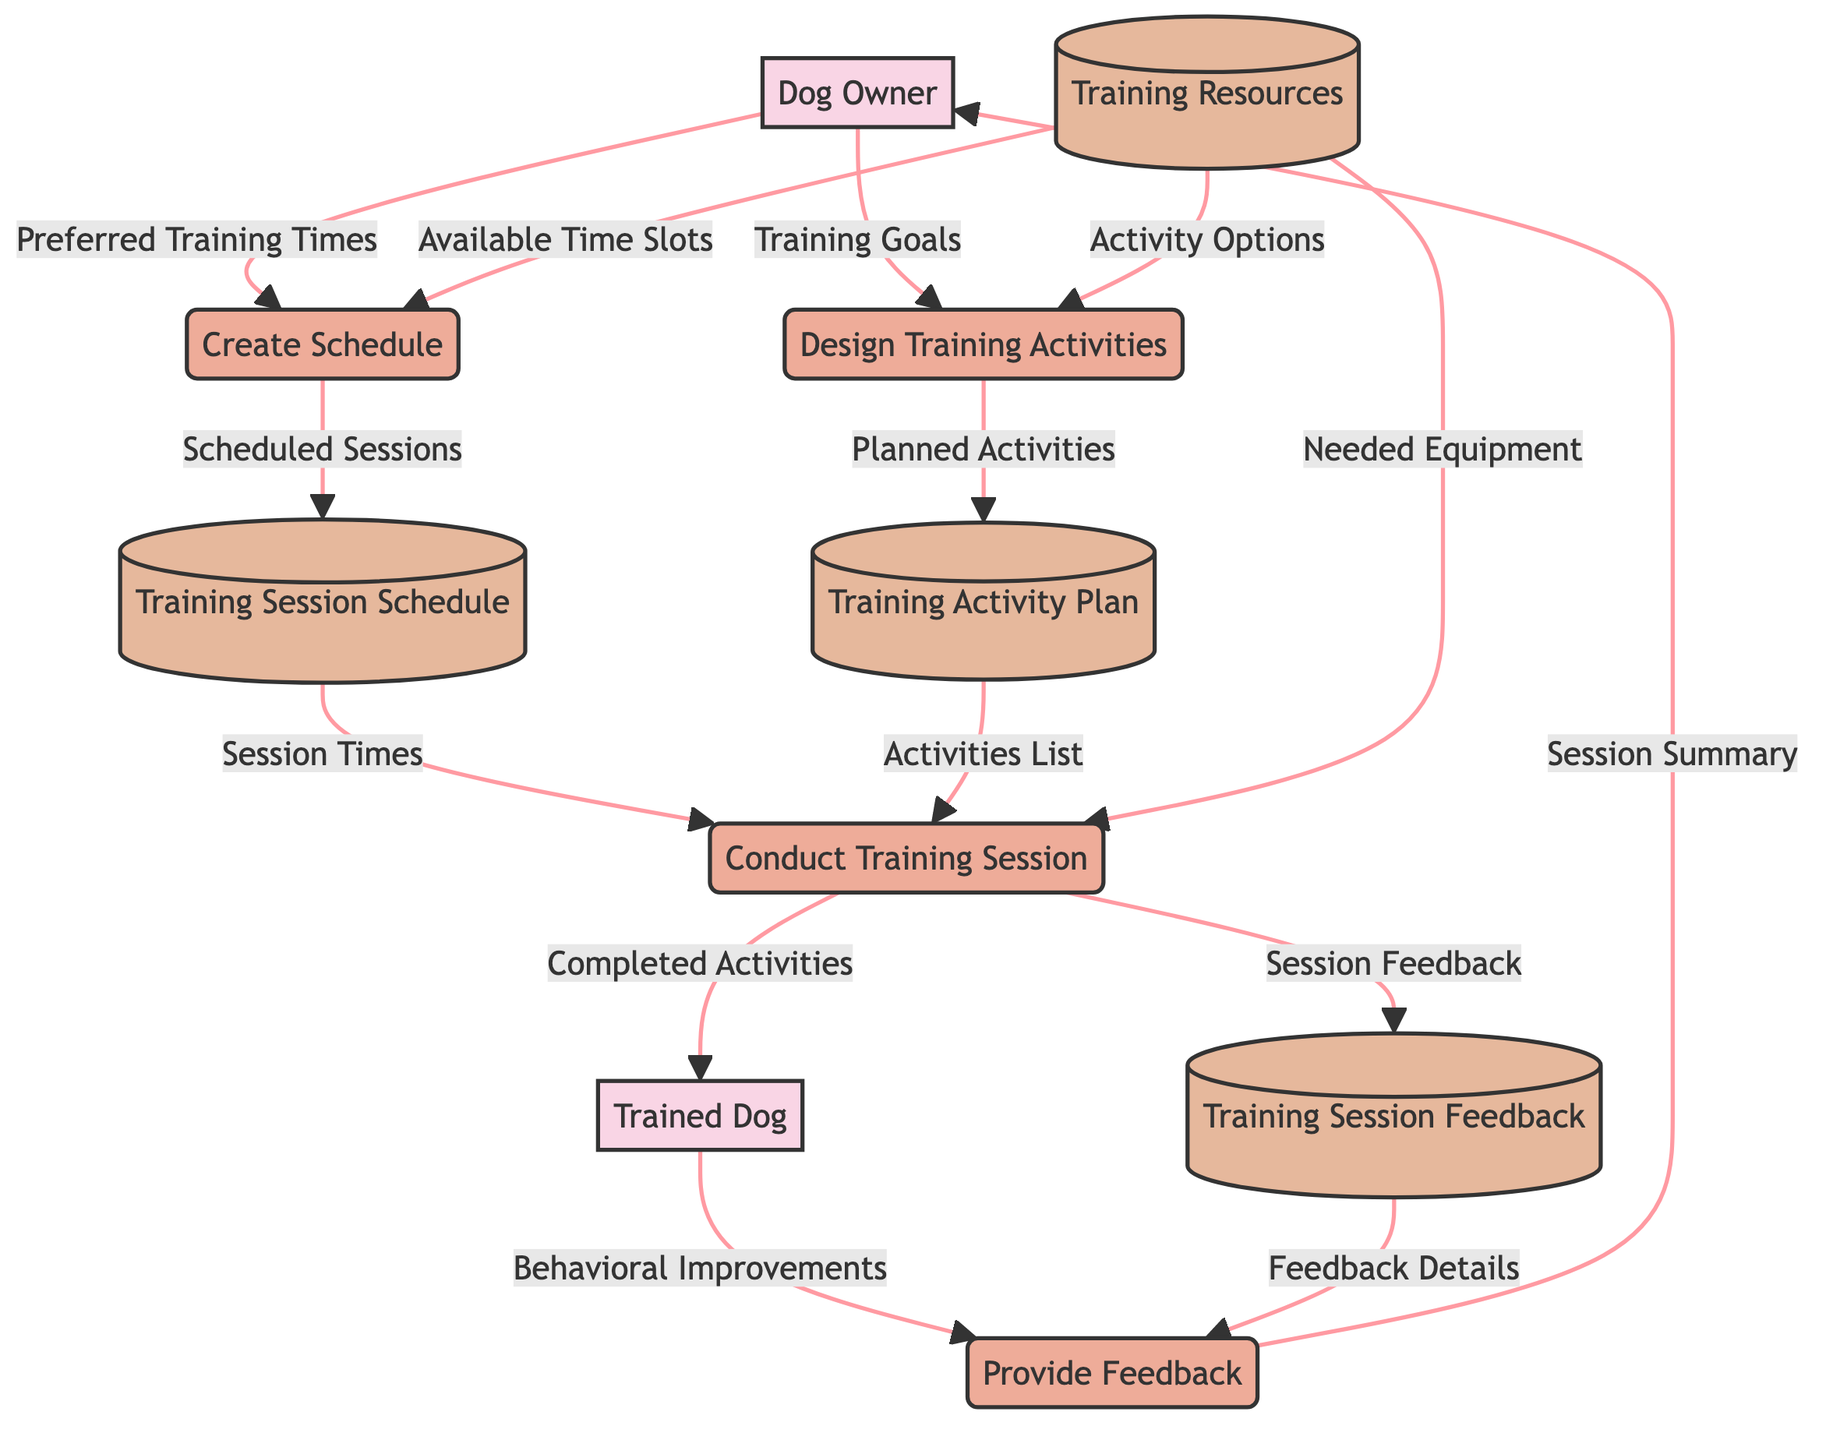What are the external entities in this diagram? The external entities listed in the diagram are "Dog Owner" and "Trained Dog". They represent the actors that interact with the processes defined in the Data Flow Diagram.
Answer: Dog Owner, Trained Dog How many data stores are present in the diagram? The diagram contains three data stores: "Training Session Schedule", "Training Activity Plan", and "Training Resources". By counting the distinct labeled storage nodes, we find a total of three.
Answer: 3 What is the output of the "Create Schedule" process? The output of the "Create Schedule" process is "Training Session Schedule". This is specified in the outputs section of the process node in the diagram.
Answer: Training Session Schedule Which process receives "Training Goals" as an input? The process that receives "Training Goals" as input is "Design Training Activities". This is indicated by the input connections leading into the process node.
Answer: Design Training Activities What data flows from "Conduct Training Session" to "Provide Feedback"? The data that flows from "Conduct Training Session" to "Provide Feedback" includes "Behavioral Improvements" and "Session Feedback". These details indicate the outputs that lead into the feedback process providing information about the training outcomes.
Answer: Behavioral Improvements, Session Feedback What data flows from "Training Resources" to "Conduct Training Session"? The data flowing from "Training Resources" to "Conduct Training Session" is "Needed Equipment". This shows that essential tools and items for conducting the training sessions are sourced from the training resources store.
Answer: Needed Equipment What is the relationship between "Dog Owner" and "Training Session Schedule"? The relationship between "Dog Owner" and "Training Session Schedule" is that the "Dog Owner" provides "Preferred Training Times" which are used to create the training session schedule. This shows the dependency and flow of information in scheduling training.
Answer: Provides Preferred Training Times How many processes are involved in the diagram? The diagram includes four processes: "Create Schedule", "Design Training Activities", "Conduct Training Session", and "Provide Feedback". By identifying the labeled process nodes in the diagram, we find there are four.
Answer: 4 What does the "Provide Feedback" process output to the "Dog Owner"? The output of the "Provide Feedback" process to the "Dog Owner" is "Session Summary". This indicates that after feedback is provided, a summary is communicated back to the owner.
Answer: Session Summary 